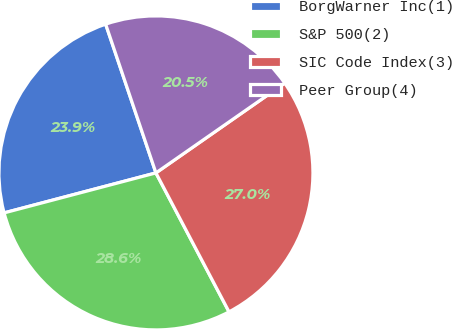<chart> <loc_0><loc_0><loc_500><loc_500><pie_chart><fcel>BorgWarner Inc(1)<fcel>S&P 500(2)<fcel>SIC Code Index(3)<fcel>Peer Group(4)<nl><fcel>23.91%<fcel>28.61%<fcel>26.98%<fcel>20.5%<nl></chart> 